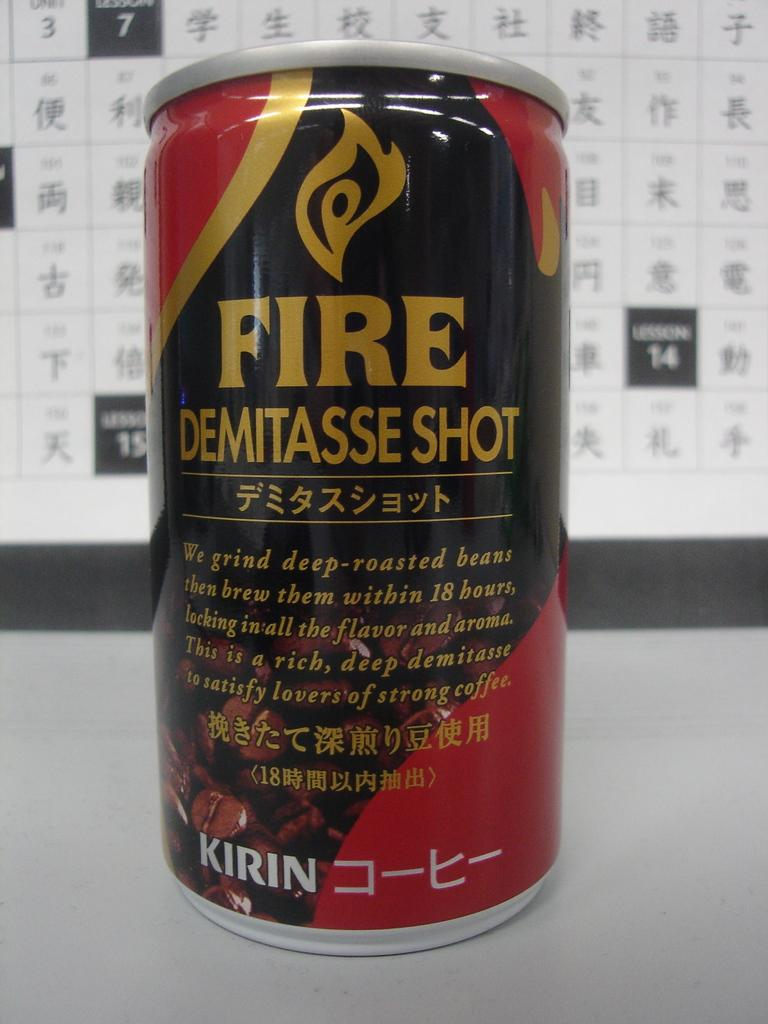<image>
Present a compact description of the photo's key features. Can of fire demitasse shot that is kirin 